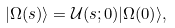Convert formula to latex. <formula><loc_0><loc_0><loc_500><loc_500>| \Omega ( s ) \rangle = \mathcal { U } ( s ; 0 ) | \Omega ( 0 ) \rangle ,</formula> 